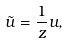<formula> <loc_0><loc_0><loc_500><loc_500>\tilde { u } = \frac { 1 } { z } u ,</formula> 